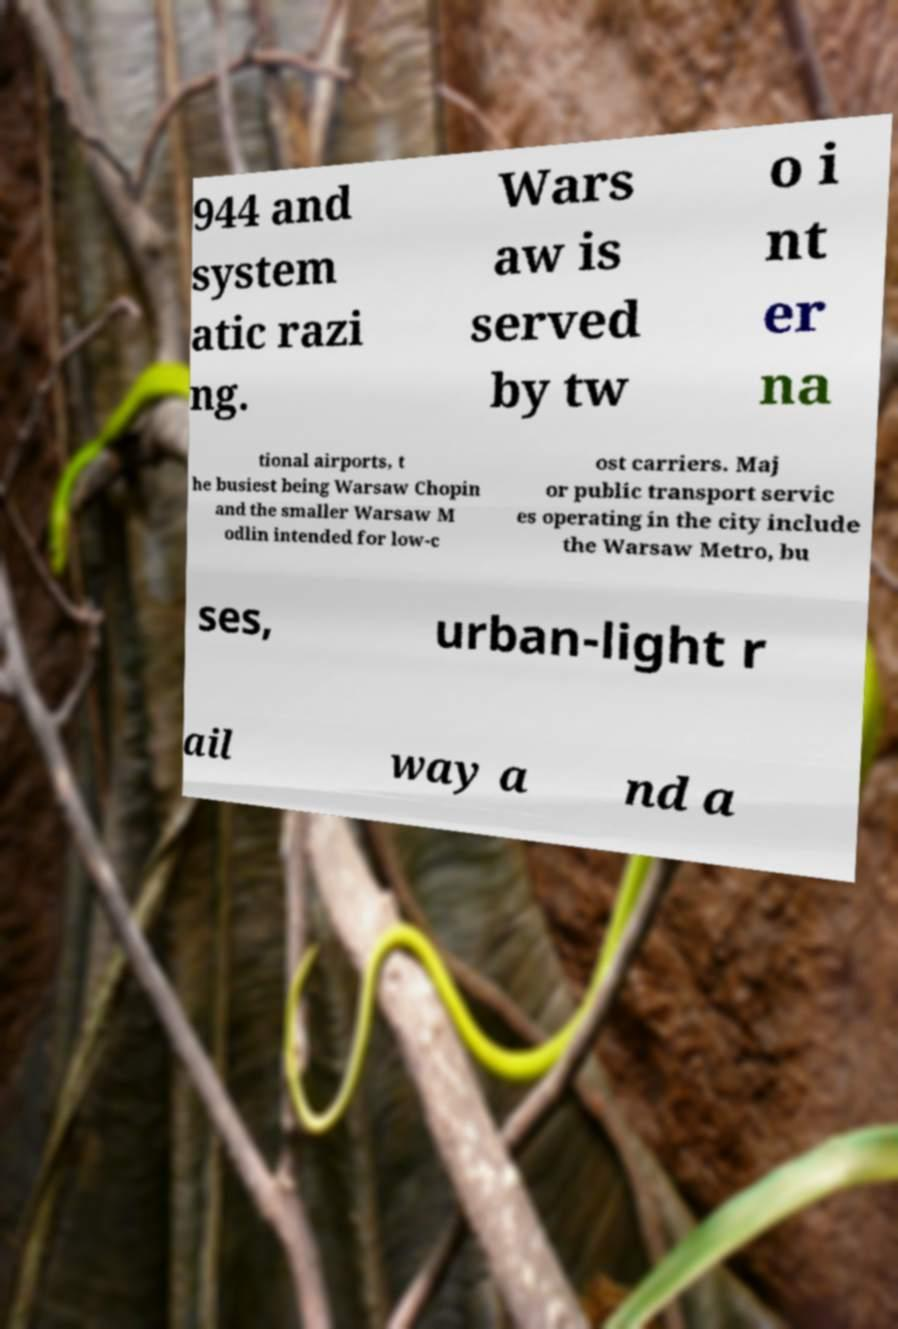I need the written content from this picture converted into text. Can you do that? 944 and system atic razi ng. Wars aw is served by tw o i nt er na tional airports, t he busiest being Warsaw Chopin and the smaller Warsaw M odlin intended for low-c ost carriers. Maj or public transport servic es operating in the city include the Warsaw Metro, bu ses, urban-light r ail way a nd a 